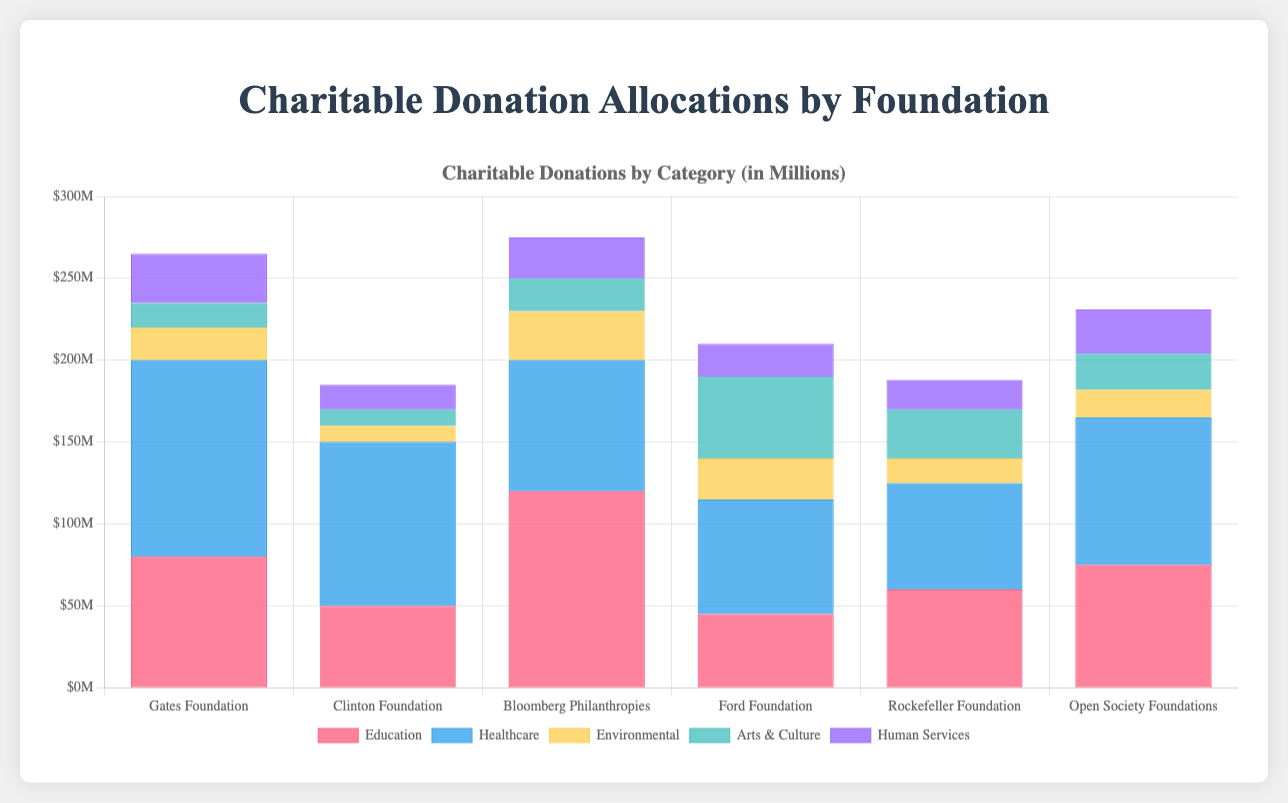How much does the Gates Foundation donate to Education and Healthcare combined? The Gates Foundation donates $80,000,000 to Education and $120,000,000 to Healthcare. Summing these amounts gives $80,000,000 + $120,000,000 = $200,000,000.
Answer: $200,000,000 Which foundation allocates the most to Environmental causes? Comparing Environmental donations: Gates Foundation ($20,000,000), Clinton Foundation ($10,000,000), Bloomberg Philanthropies ($30,000,000), Ford Foundation ($25,000,000), Rockefeller Foundation ($15,000,000), Open Society Foundations ($17,000,000). Bloomberg Philanthropies has the highest allocation.
Answer: Bloomberg Philanthropies What is the total amount donated to Human Services by all foundations? Sum the Human Services donations from each foundation: Gates Foundation ($30,000,000), Clinton Foundation ($15,000,000), Bloomberg Philanthropies ($25,000,000), Ford Foundation ($20,000,000), Rockefeller Foundation ($18,000,000), Open Society Foundations ($27,000,000). $30,000,000 + $15,000,000 + $25,000,000 + $20,000,000 + $18,000,000 + $27,000,000 = $135,000,000.
Answer: $135,000,000 Between Rockefeller Foundation and Ford Foundation, which donates more to Arts & Culture? Rockefeller Foundation donates $30,000,000 and Ford Foundation donates $50,000,000 to Arts & Culture. Ford Foundation donates more.
Answer: Ford Foundation What is the average donation to Education by the foundations? Sum the Education donations from each foundation: Gates Foundation ($80,000,000), Clinton Foundation ($50,000,000), Bloomberg Philanthropies ($120,000,000), Ford Foundation ($45,000,000), Rockefeller Foundation ($60,000,000), Open Society Foundations ($75,000,000). Total = $80,000,000 + $50,000,000 + $120,000,000 + $45,000,000 + $60,000,000 + $75,000,000 = $430,000,000. Average = $430,000,000 / 6 = $71,666,667.
Answer: $71,666,667 How much more does the Bloomberg Philanthropies donate to Education than the Clinton Foundation? Bloomberg Philanthropies donates $120,000,000 and Clinton Foundation donates $50,000,000 to Education. Difference = $120,000,000 - $50,000,000 = $70,000,000.
Answer: $70,000,000 Which category receives the least amount of donation from the Open Society Foundations? Comparing categories from Open Society Foundations: Education ($75,000,000), Healthcare ($90,000,000), Environmental ($17,000,000), Arts & Culture ($22,000,000), Human Services ($27,000,000). Environmental receives the least, $17,000,000.
Answer: Environmental If you sum up the donations of Ford Foundation to Education, Healthcare, and Environmental causes, what is the total amount? Sum the Education ($45,000,000), Healthcare ($70,000,000), and Environmental ($25,000,000) donations from Ford Foundation. Total = $45,000,000 + $70,000,000 + $25,000,000 = $140,000,000.
Answer: $140,000,000 What is the median donation amount in Healthcare across all foundations? List Healthcare donations: Gates Foundation ($120,000,000), Clinton Foundation ($100,000,000), Bloomberg Philanthropies ($80,000,000), Ford Foundation ($70,000,000), Rockefeller Foundation ($65,000,000), Open Society Foundations ($90,000,000). Ordered: $65,000,000, $70,000,000, $80,000,000, $90,000,000, $100,000,000, $120,000,000. Median = ($80,000,000 + $90,000,000) / 2 = $85,000,000.
Answer: $85,000,000 